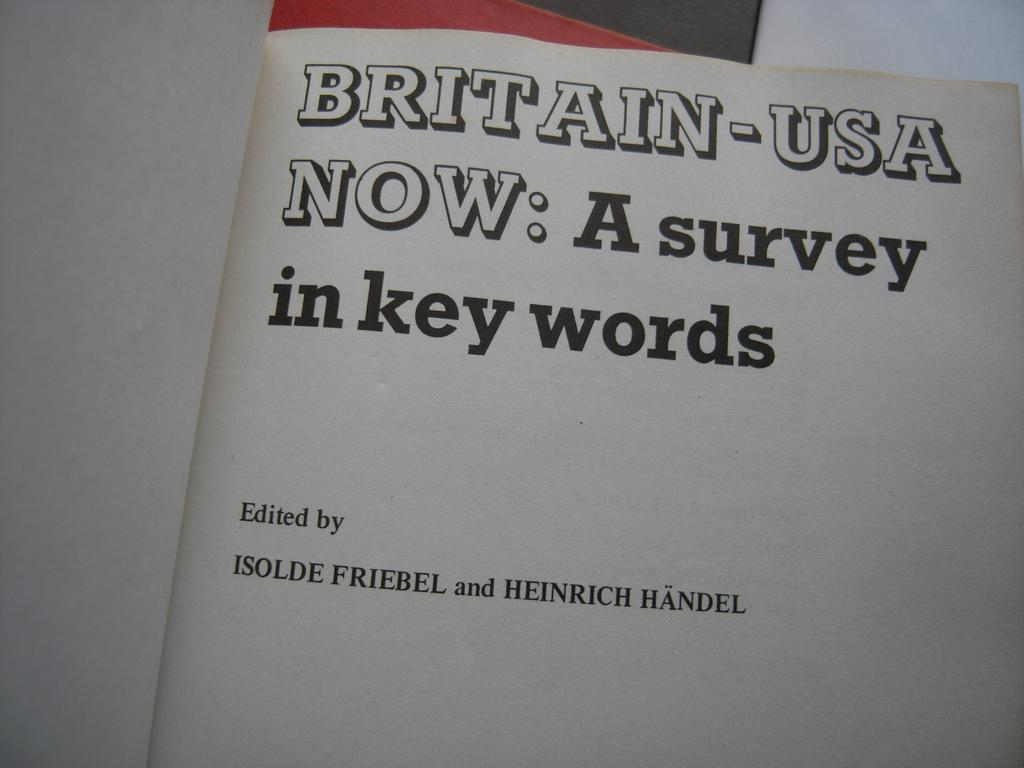<image>
Share a concise interpretation of the image provided. Britain-USA Now: A survey in key words edited by Isolde Friebel and Heinrich Handel. 